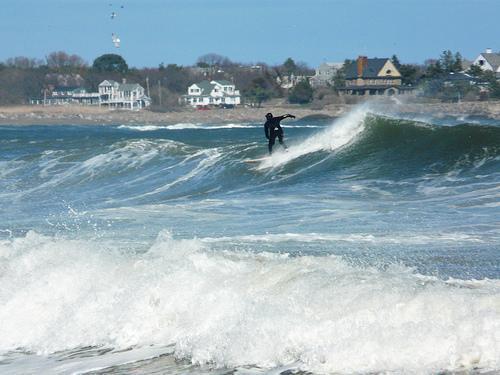How many people are in the picture?
Give a very brief answer. 1. 